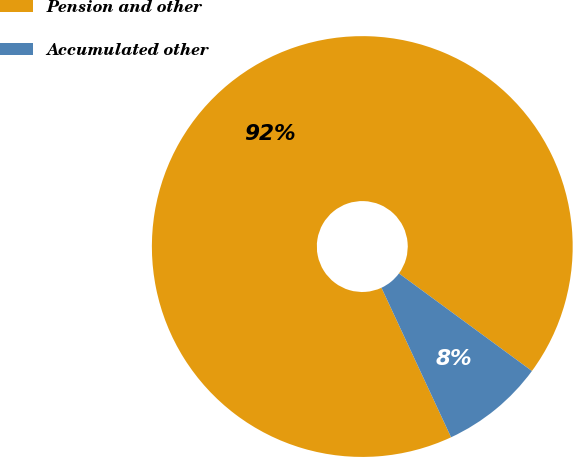<chart> <loc_0><loc_0><loc_500><loc_500><pie_chart><fcel>Pension and other<fcel>Accumulated other<nl><fcel>92.01%<fcel>7.99%<nl></chart> 